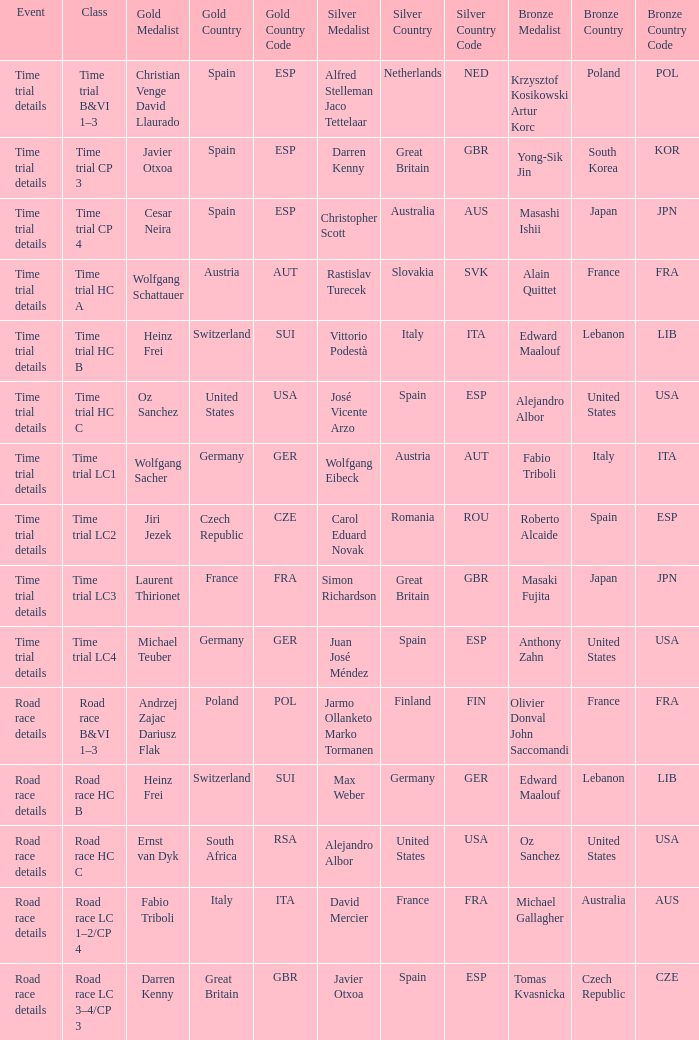Who received gold when the event is time trial details and silver is simon richardson great britain (gbr)? Laurent Thirionet France (FRA). 